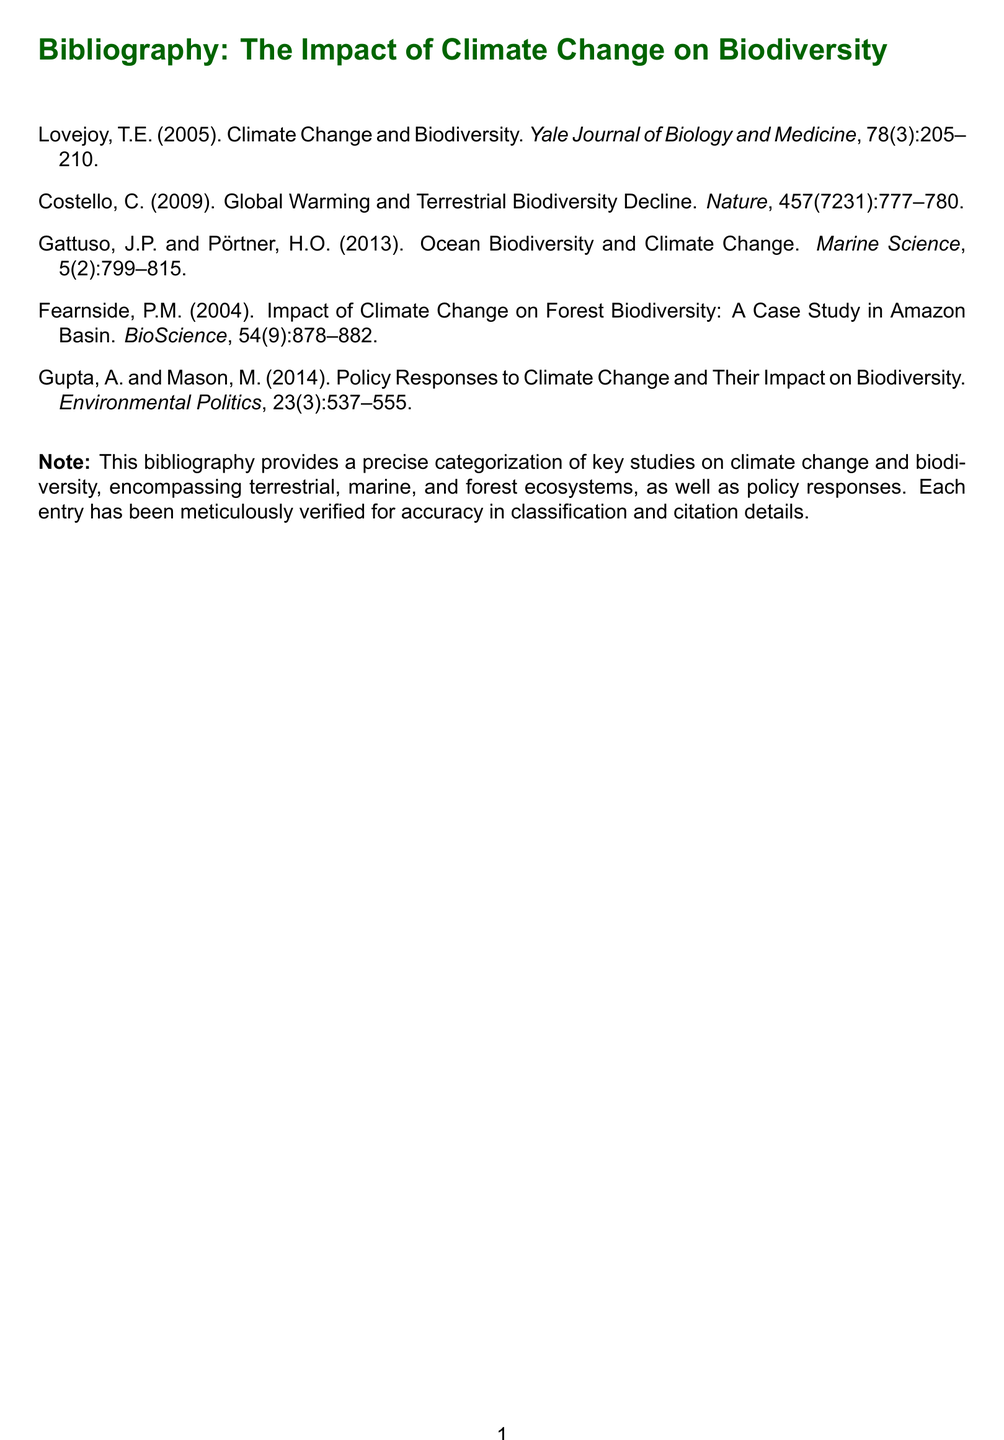What is the title of the first listed work? The title is directly cited in the bibliography under the first author, which is Lovejoy (2005).
Answer: Climate Change and Biodiversity What journal published the second work? The journal is mentioned in the citation for Costello (2009).
Answer: Nature Who are the authors of the third entry? The authors are listed at the beginning of the citation for Gattuso and Pörtner (2013).
Answer: Gattuso, J.P. and Pörtner, H.O What year was the case study on the Amazon Basin published? The year is included in the citation for Fearnside (2004).
Answer: 2004 What volume number is associated with the last bibliography entry? Each entry lists its volume number, which is found under Gupta and Mason (2014).
Answer: 23 How many entries are in the bibliography? The total number of entries provided in the document is explicitly stated.
Answer: 5 What is the main focus of Gupta and Mason's work? The focus can be derived from the title of their entry in the bibliography.
Answer: Policy Responses to Climate Change and Their Impact on Biodiversity What type of ecosystems does the bibliography cover? The types of ecosystems are described in the note, summarizing the web of entries.
Answer: Terrestrial, marine, and forest ecosystems In what year is the oldest study cited published? The year can be found in the citation for Lovejoy (2005) versus the other years.
Answer: 2005 